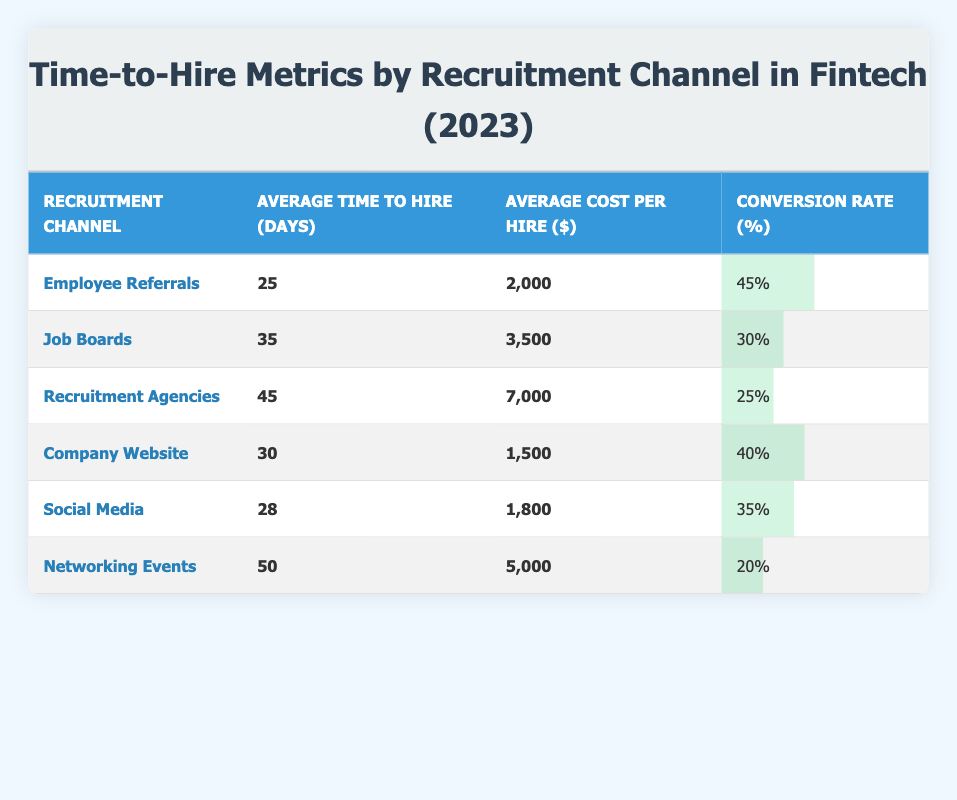What is the average time to hire for Employee Referrals? According to the table, the average time to hire for Employee Referrals is listed directly in the row corresponding to that channel, which is 25 days.
Answer: 25 Which recruitment channel has the highest conversion rate? By examining the Conversion Rate column, Employee Referrals exhibits the highest rate at 45%, making it the channel with the highest conversion rate.
Answer: Employee Referrals What is the average cost per hire for Recruitment Agencies? The table directly shows the average cost per hire for Recruitment Agencies is $7,000, as indicated in the corresponding row of the table.
Answer: 7000 What is the total average time to hire for all channels combined? To compute this, we sum the average time to hire for all channels: (25 + 35 + 45 + 30 + 28 + 50) = 213. Then, we divide by the number of channels (6) to get the average: 213/6 = 35.5.
Answer: 35.5 Is the average cost per hire for the Company Website less than $2,000? The table indicates that the average cost per hire for the Company Website is $1,500. Since $1,500 is less than $2,000, the answer is true.
Answer: Yes What is the difference between the conversion rates of Job Boards and Networking Events? The conversion rate for Job Boards is 30% and for Networking Events, it is 20%. The difference is calculated as 30 - 20 = 10.
Answer: 10 What is the average cost per hire for the five channels other than Recruitment Agencies? We identify the channels and their costs (Employee Referrals: 2000, Job Boards: 3500, Company Website: 1500, Social Media: 1800, Networking Events: 5000). Summing these gives: 2000 + 3500 + 1500 + 1800 + 5000 = 15800. Dividing by 5 results in an average of 3160.
Answer: 3160 Are there any channels where the average time to hire exceeds 45 days? The table shows that the only channel with an average time to hire over 45 days is Networking Events, which has an average time of 50 days. Therefore, the answer is yes.
Answer: Yes How does the average cost per hire for Social Media compare to that of the Company Website? The average cost per hire for Social Media is $1,800, while for the Company Website it is $1,500. Since $1,800 is greater than $1,500, Social Media has a higher cost per hire.
Answer: Higher 